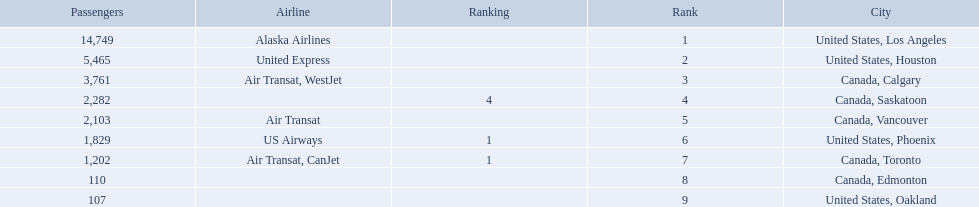What are the cities that are associated with the playa de oro international airport? United States, Los Angeles, United States, Houston, Canada, Calgary, Canada, Saskatoon, Canada, Vancouver, United States, Phoenix, Canada, Toronto, Canada, Edmonton, United States, Oakland. What is uniteed states, los angeles passenger count? 14,749. What other cities passenger count would lead to 19,000 roughly when combined with previous los angeles? Canada, Calgary. 